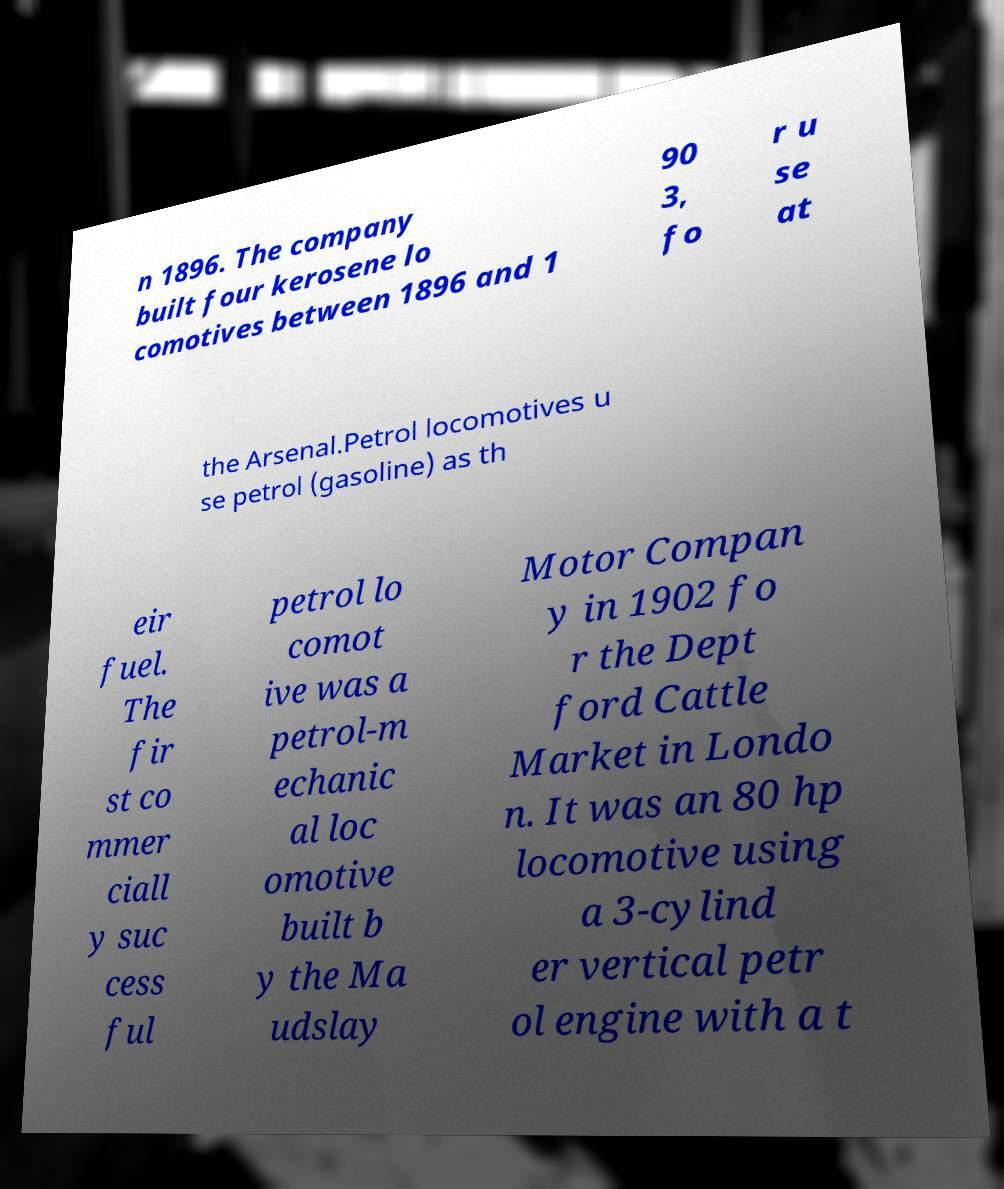Can you read and provide the text displayed in the image?This photo seems to have some interesting text. Can you extract and type it out for me? n 1896. The company built four kerosene lo comotives between 1896 and 1 90 3, fo r u se at the Arsenal.Petrol locomotives u se petrol (gasoline) as th eir fuel. The fir st co mmer ciall y suc cess ful petrol lo comot ive was a petrol-m echanic al loc omotive built b y the Ma udslay Motor Compan y in 1902 fo r the Dept ford Cattle Market in Londo n. It was an 80 hp locomotive using a 3-cylind er vertical petr ol engine with a t 